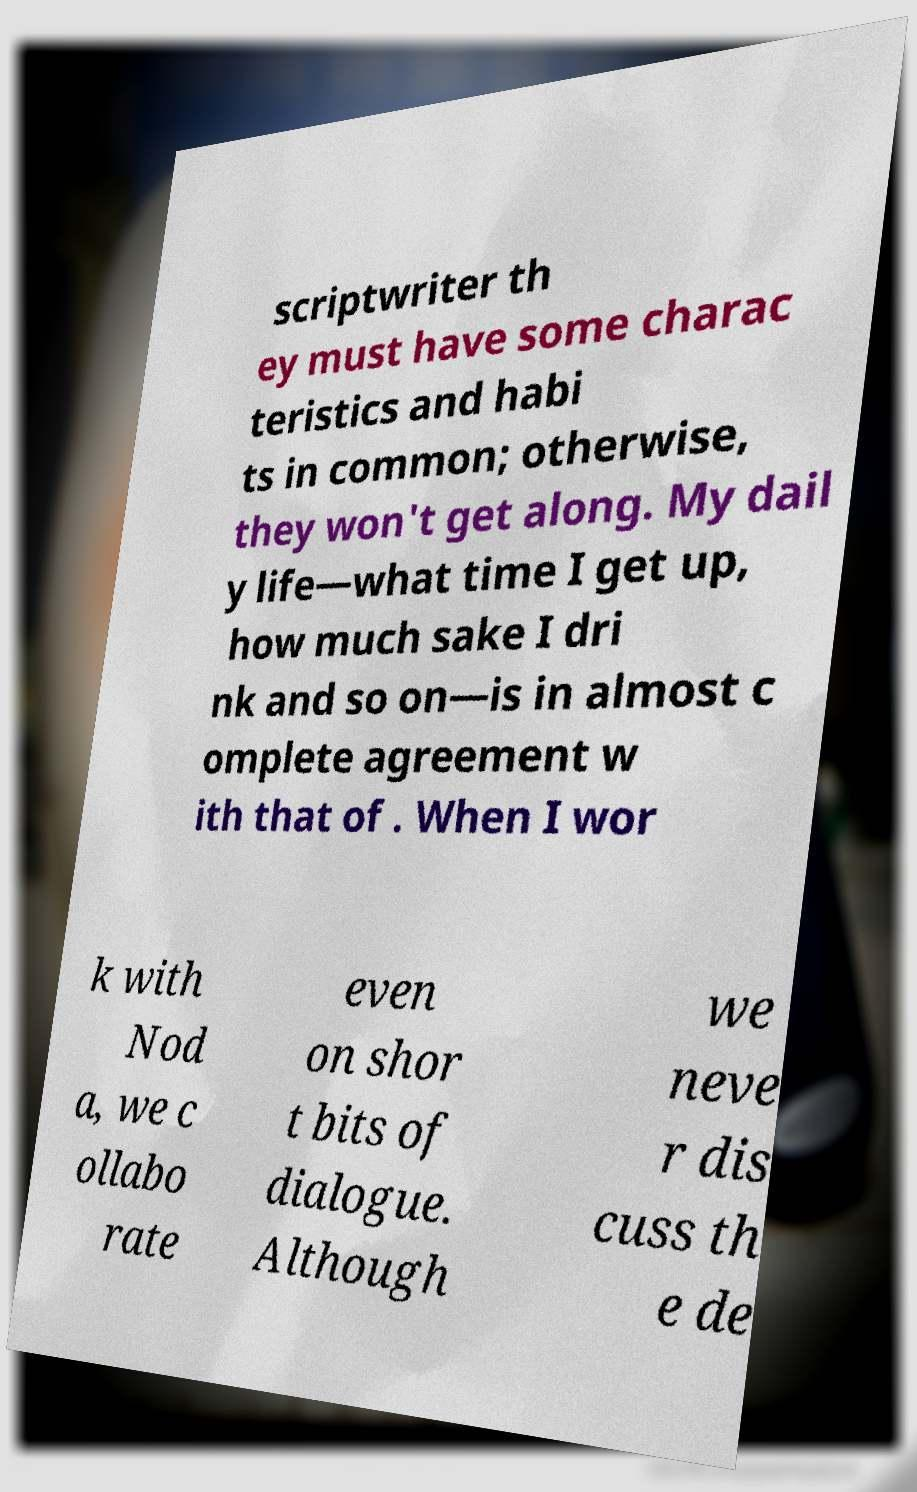Could you assist in decoding the text presented in this image and type it out clearly? scriptwriter th ey must have some charac teristics and habi ts in common; otherwise, they won't get along. My dail y life—what time I get up, how much sake I dri nk and so on—is in almost c omplete agreement w ith that of . When I wor k with Nod a, we c ollabo rate even on shor t bits of dialogue. Although we neve r dis cuss th e de 